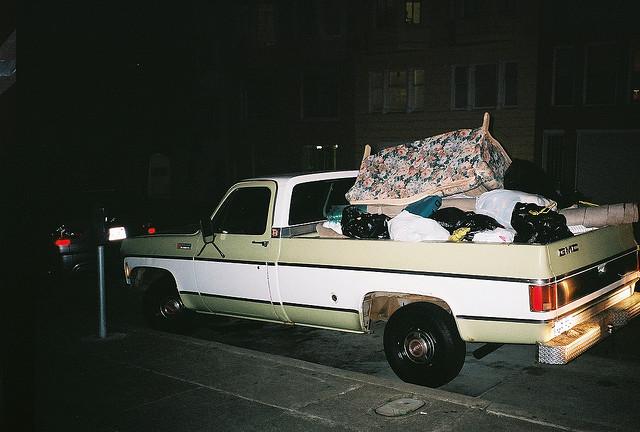What is on the back of the truck?
Keep it brief. Garbage. When did this scene take place?
Concise answer only. Night. What type of truck is in the picture?
Write a very short answer. Pickup. What color is this vehicle?
Write a very short answer. White and green. 